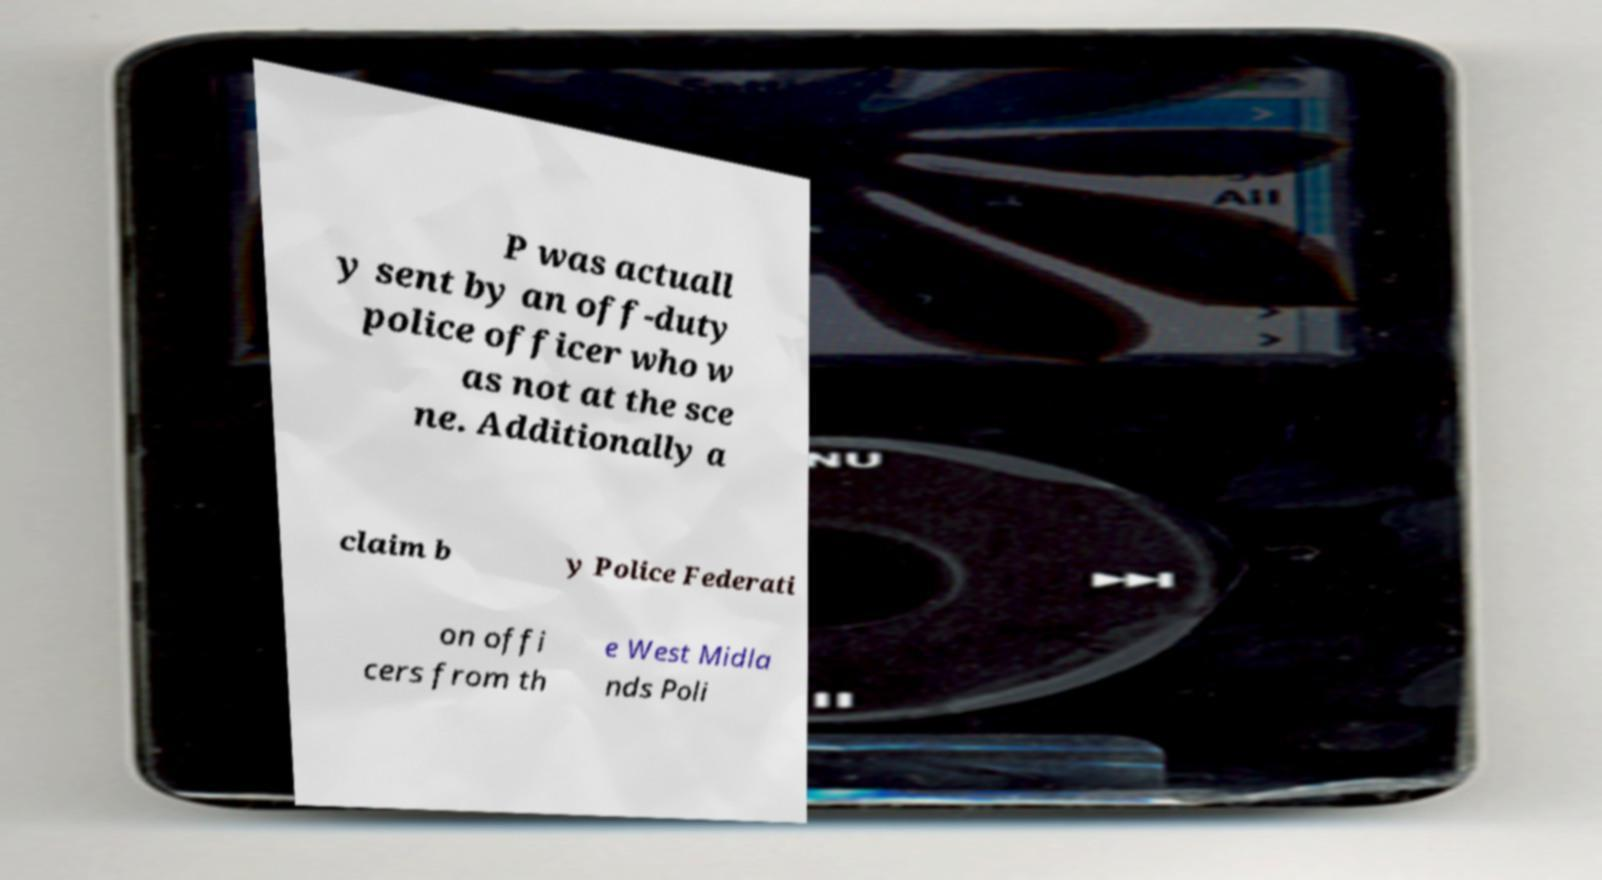I need the written content from this picture converted into text. Can you do that? P was actuall y sent by an off-duty police officer who w as not at the sce ne. Additionally a claim b y Police Federati on offi cers from th e West Midla nds Poli 